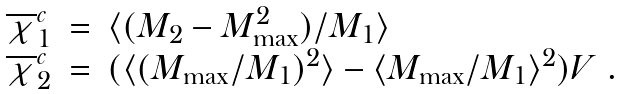<formula> <loc_0><loc_0><loc_500><loc_500>\begin{array} { l c l } \overline { \chi } _ { 1 } ^ { c } & = & \langle ( M _ { 2 } - M _ { \max } ^ { 2 } ) / M _ { 1 } \rangle \\ \overline { \chi } _ { 2 } ^ { c } & = & ( \langle ( M _ { \max } / M _ { 1 } ) ^ { 2 } \rangle - \langle M _ { \max } / M _ { 1 } \rangle ^ { 2 } ) V \ . \end{array}</formula> 